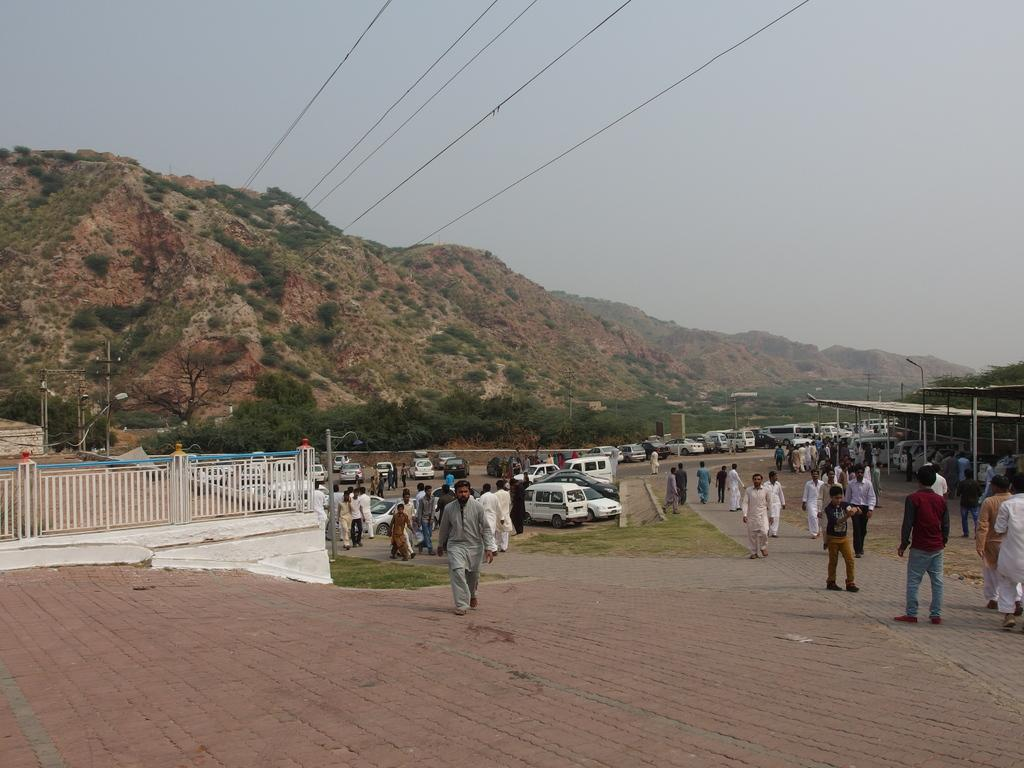How many people are in the image? There is a group of people in the image. What are the people doing in the image? The people are walking on the ground in the image. What structures can be seen in the image? There are shelters and poles in the image. What type of barrier is present in the image? There is a fence in the image. What natural features are visible in the image? There are mountains, grass, trees, and the sky visible in the image. What else can be seen in the image? There are wires in the image. What type of cannon is present in the image? There is no cannon present in the image. Is this a family gathering, and who are the family members? The provided facts do not mention any family members or gatherings, so we cannot determine if it is a family gathering or identify the family members. What type of street can be seen in the image? There is no street present in the image; it features a group of people walking on the ground with various structures and natural features in the background. 